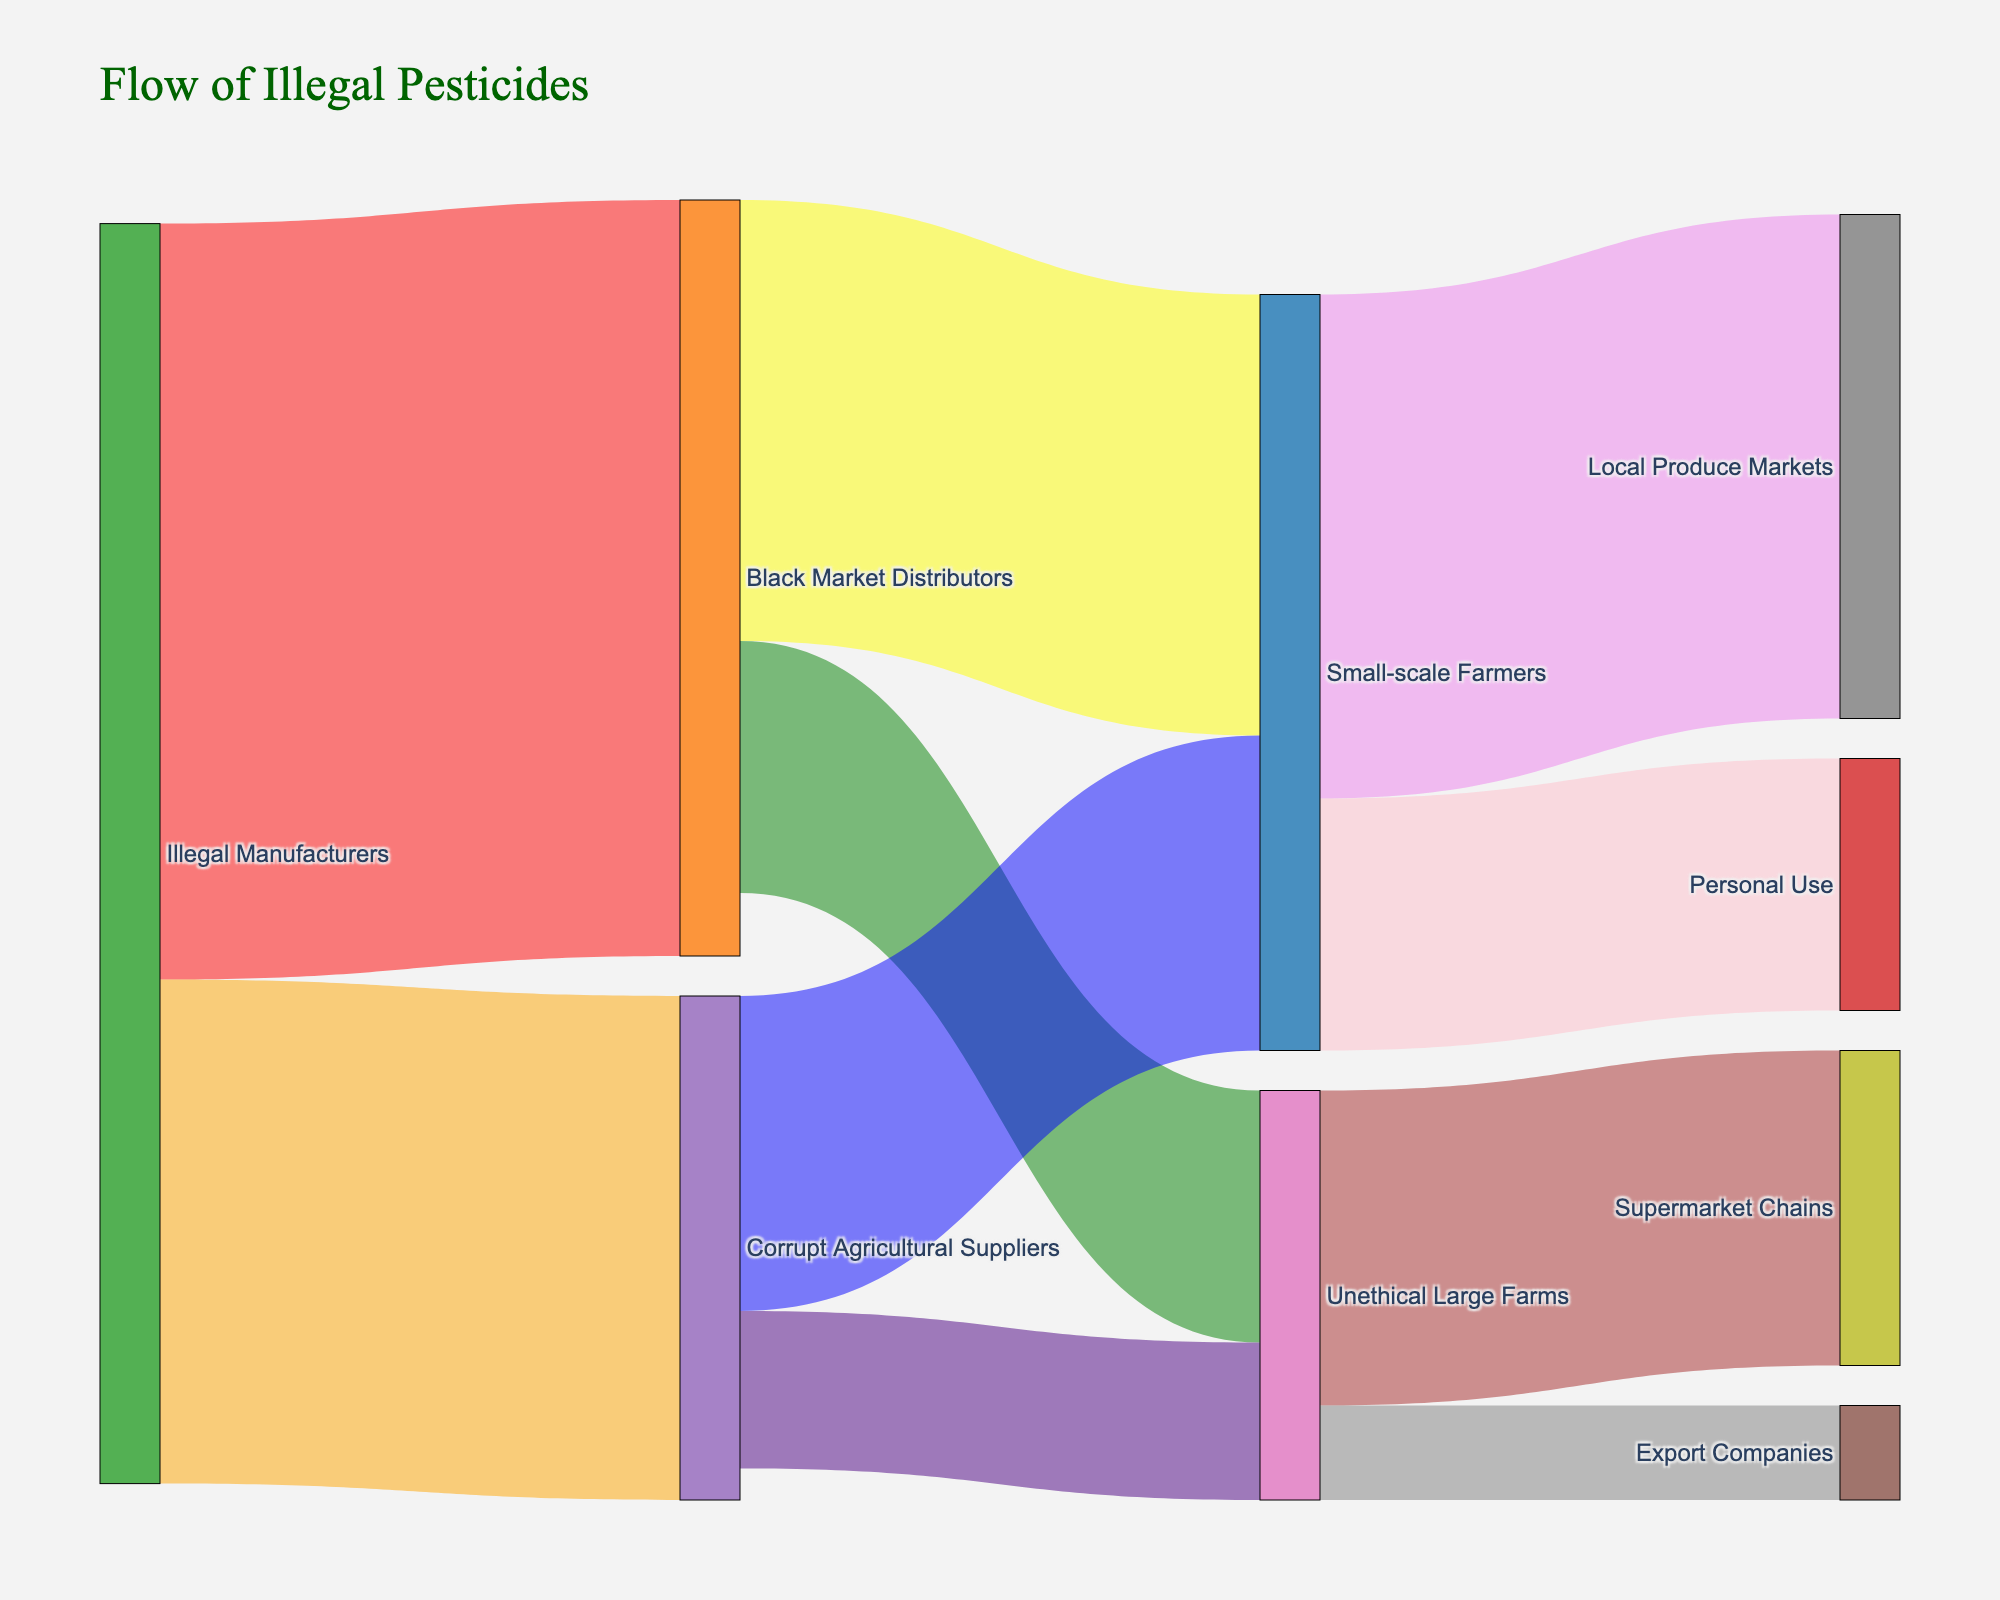Who are the primary sources in the flow of illegal pesticides? The primary sources in the flow are the "Illegal Manufacturers". This can be seen as they connect to both "Black Market Distributors" and "Corrupt Agricultural Suppliers".
Answer: Illegal Manufacturers What is the total amount of illegal pesticides that illegally manufactured? The illegal pesticide flow starts from Illegal Manufacturers to Black Market Distributors (1200) and Corrupt Agricultural Suppliers (800). Adding these amounts gives 1200 + 800.
Answer: 2000 Which group has the largest single flow of illegal pesticides? The largest single flow can be identified by finding the highest value among all connections. The connection with the highest value is 1200 from Illegal Manufacturers to Black Market Distributors.
Answer: Illegal Manufacturers to Black Market Distributors Compare the total illegal pesticide flow to "Small-scale Farmers" versus "Unethical Large Farms". Which is greater? Adding flows to "Small-scale Farmers" from Black Market Distributors (700) and Corrupt Agricultural Suppliers (500) totals 1200. Flows to "Unethical Large Farms" from the same sources are 400 + 250, totaling 650.
Answer: Small-scale Farmers What is the total amount of illegal pesticides that reaches local and international markets? Total flows to local markets (Small-scale Farmers to Local Produce Markets 800) and personal use (Small-scale Farmers to Personal Use 400) totals 800 + 400. Total flows to international markets (Unethical Large Farms to Export Companies 150). Summed, 1200 + 150.
Answer: 1350 Identify the group associated with exports in the flow of illegal pesticides. By tracing the paths that end at "Export Companies", it is evident that the origin group is "Unethical Large Farms".
Answer: Unethical Large Farms How many different groups are involved in the illegal pesticide flow from source to final users? Counting all unique groups involved: Illegal Manufacturers, Black Market Distributors, Corrupt Agricultural Suppliers, Small-scale Farmers, Unethical Large Farms, Local Produce Markets, Personal Use, Supermarket Chains, Export Companies.
Answer: 9 Is the flow to Unethical Large Farms greater from Black Market Distributors or Corrupt Agricultural Suppliers? Comparing the amounts from the respective sources is necessary. The Black Market Distributors contribute 400 while Corrupt Agricultural Suppliers contribute 250.
Answer: Black Market Distributors For the Illegal Manufacturers, which of its next connections handle larger flow quantities? Illegal Manufacturers link to Black Market Distributors (1200) and Corrupt Agricultural Suppliers (800).
Answer: Black Market Distributors To which final destination do Unethical Large Farms send the majority of illegal pesticides? Unethical Large Farms connect to Supermarket Chains (500) and Export Companies (150). The larger value is 500.
Answer: Supermarket Chains 